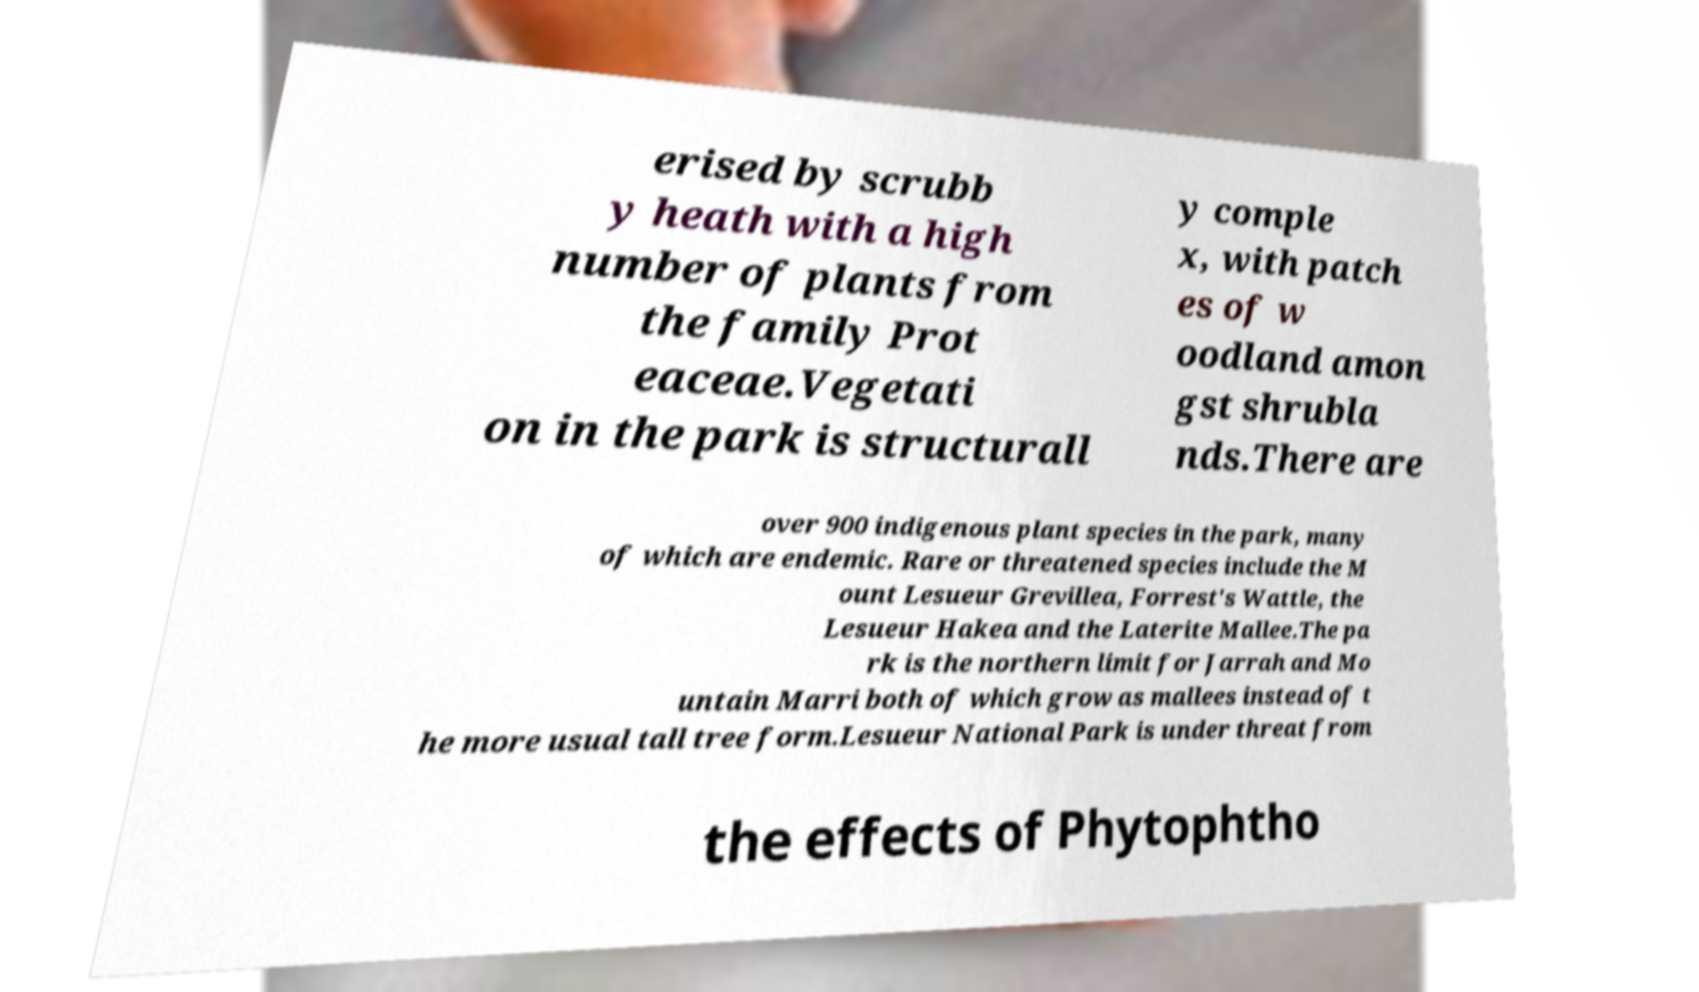For documentation purposes, I need the text within this image transcribed. Could you provide that? erised by scrubb y heath with a high number of plants from the family Prot eaceae.Vegetati on in the park is structurall y comple x, with patch es of w oodland amon gst shrubla nds.There are over 900 indigenous plant species in the park, many of which are endemic. Rare or threatened species include the M ount Lesueur Grevillea, Forrest's Wattle, the Lesueur Hakea and the Laterite Mallee.The pa rk is the northern limit for Jarrah and Mo untain Marri both of which grow as mallees instead of t he more usual tall tree form.Lesueur National Park is under threat from the effects of Phytophtho 